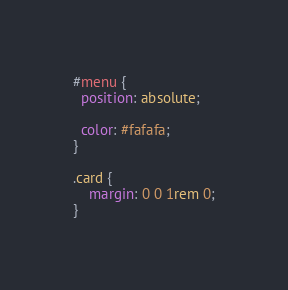Convert code to text. <code><loc_0><loc_0><loc_500><loc_500><_CSS_>#menu {
  position: absolute;

  color: #fafafa;
}

.card {
    margin: 0 0 1rem 0;
}</code> 